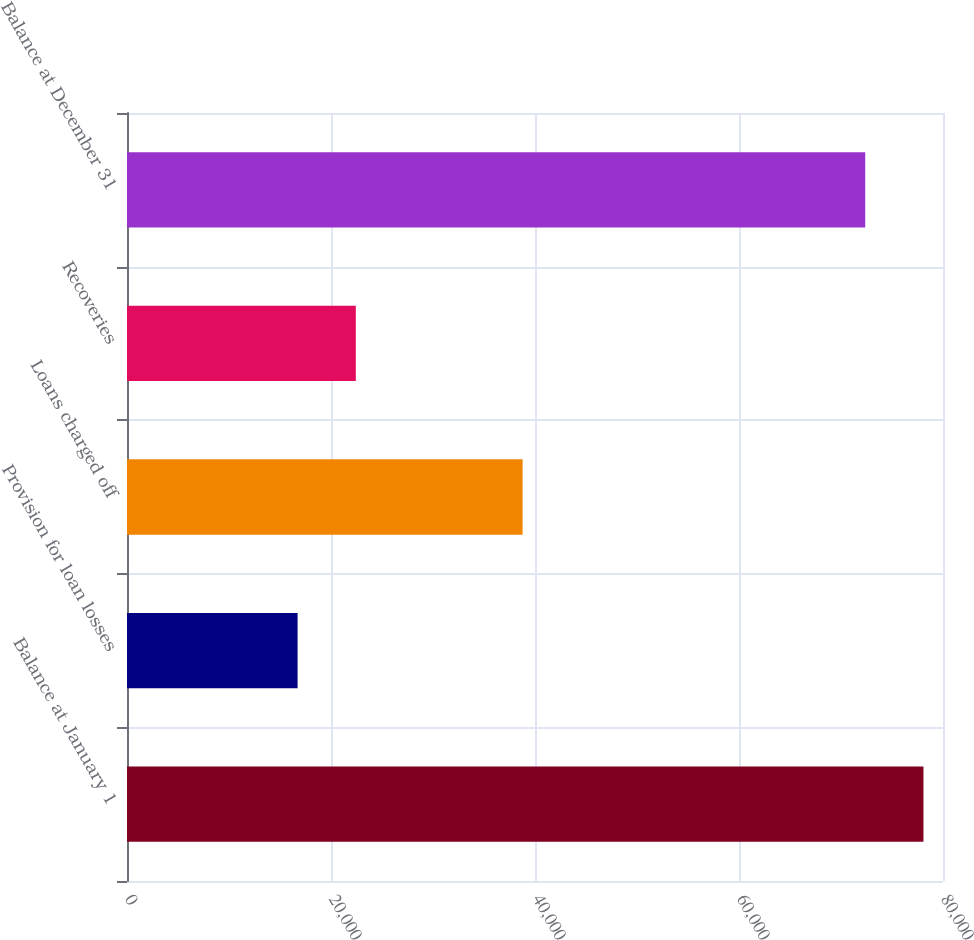Convert chart to OTSL. <chart><loc_0><loc_0><loc_500><loc_500><bar_chart><fcel>Balance at January 1<fcel>Provision for loan losses<fcel>Loans charged off<fcel>Recoveries<fcel>Balance at December 31<nl><fcel>78082.6<fcel>16724<fcel>38785<fcel>22431.6<fcel>72375<nl></chart> 